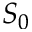Convert formula to latex. <formula><loc_0><loc_0><loc_500><loc_500>S _ { 0 }</formula> 